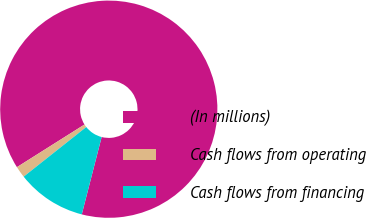<chart> <loc_0><loc_0><loc_500><loc_500><pie_chart><fcel>(In millions)<fcel>Cash flows from operating<fcel>Cash flows from financing<nl><fcel>87.96%<fcel>1.71%<fcel>10.33%<nl></chart> 